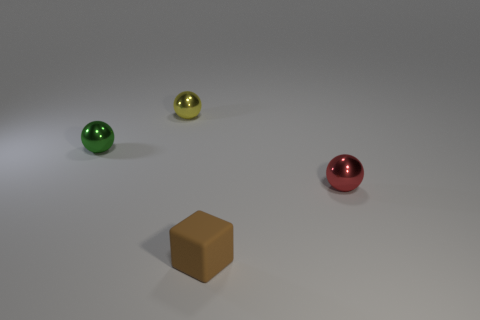The tiny green object that is the same material as the tiny red sphere is what shape?
Keep it short and to the point. Sphere. Is the shape of the metallic object that is on the right side of the small brown cube the same as  the yellow thing?
Make the answer very short. Yes. What number of brown spheres are the same size as the red shiny object?
Your answer should be very brief. 0. What number of purple objects are balls or tiny cubes?
Provide a short and direct response. 0. What number of objects are small green metallic things or balls that are in front of the tiny green sphere?
Provide a succinct answer. 2. What is the material of the small brown thing on the right side of the yellow shiny ball?
Your answer should be compact. Rubber. There is a green thing that is the same size as the brown object; what is its shape?
Offer a very short reply. Sphere. Is there another rubber thing that has the same shape as the yellow thing?
Provide a short and direct response. No. Is the material of the small brown object the same as the ball in front of the small green metallic ball?
Provide a short and direct response. No. What material is the sphere that is on the right side of the small ball that is behind the small green shiny thing?
Provide a short and direct response. Metal. 